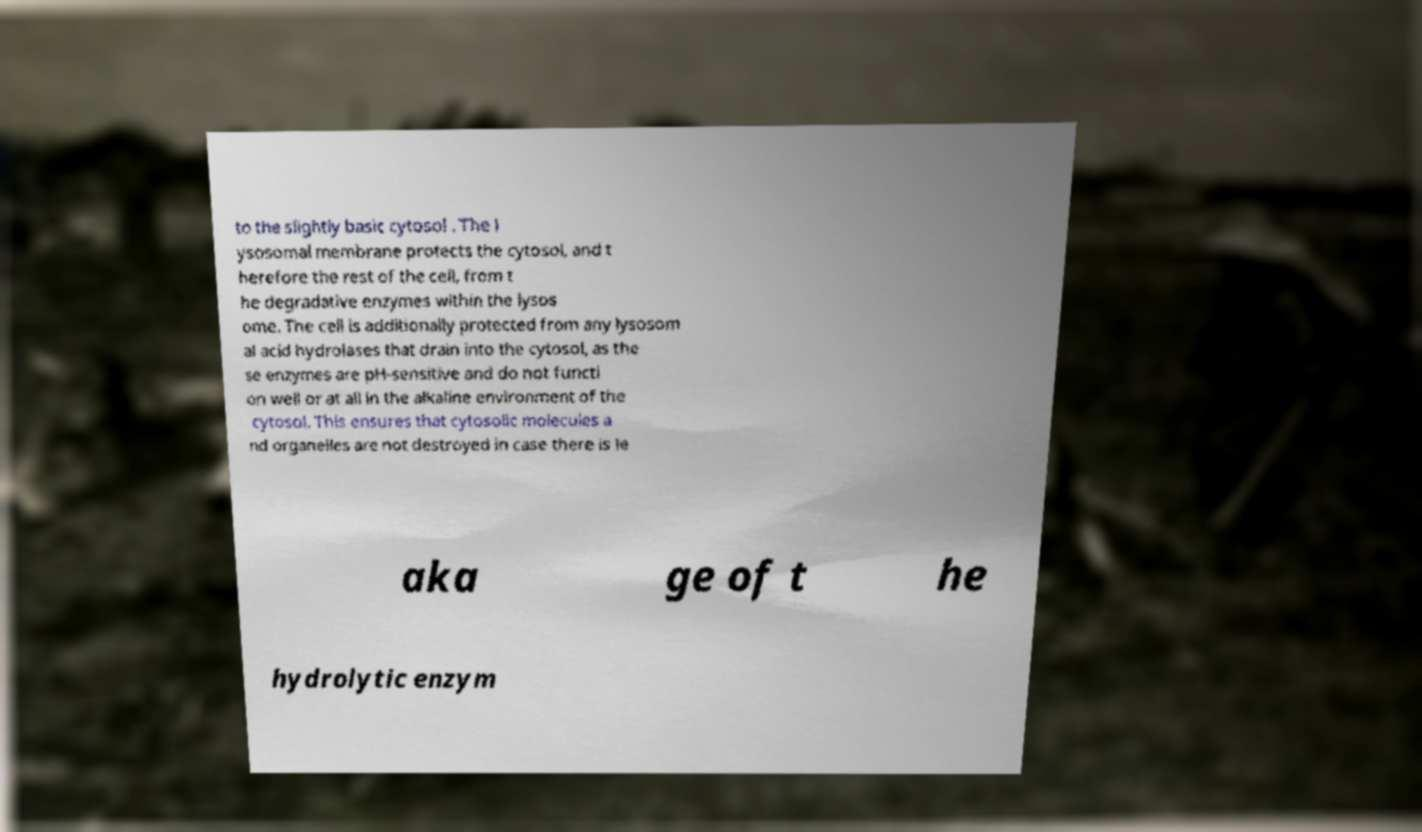Please read and relay the text visible in this image. What does it say? to the slightly basic cytosol . The l ysosomal membrane protects the cytosol, and t herefore the rest of the cell, from t he degradative enzymes within the lysos ome. The cell is additionally protected from any lysosom al acid hydrolases that drain into the cytosol, as the se enzymes are pH-sensitive and do not functi on well or at all in the alkaline environment of the cytosol. This ensures that cytosolic molecules a nd organelles are not destroyed in case there is le aka ge of t he hydrolytic enzym 